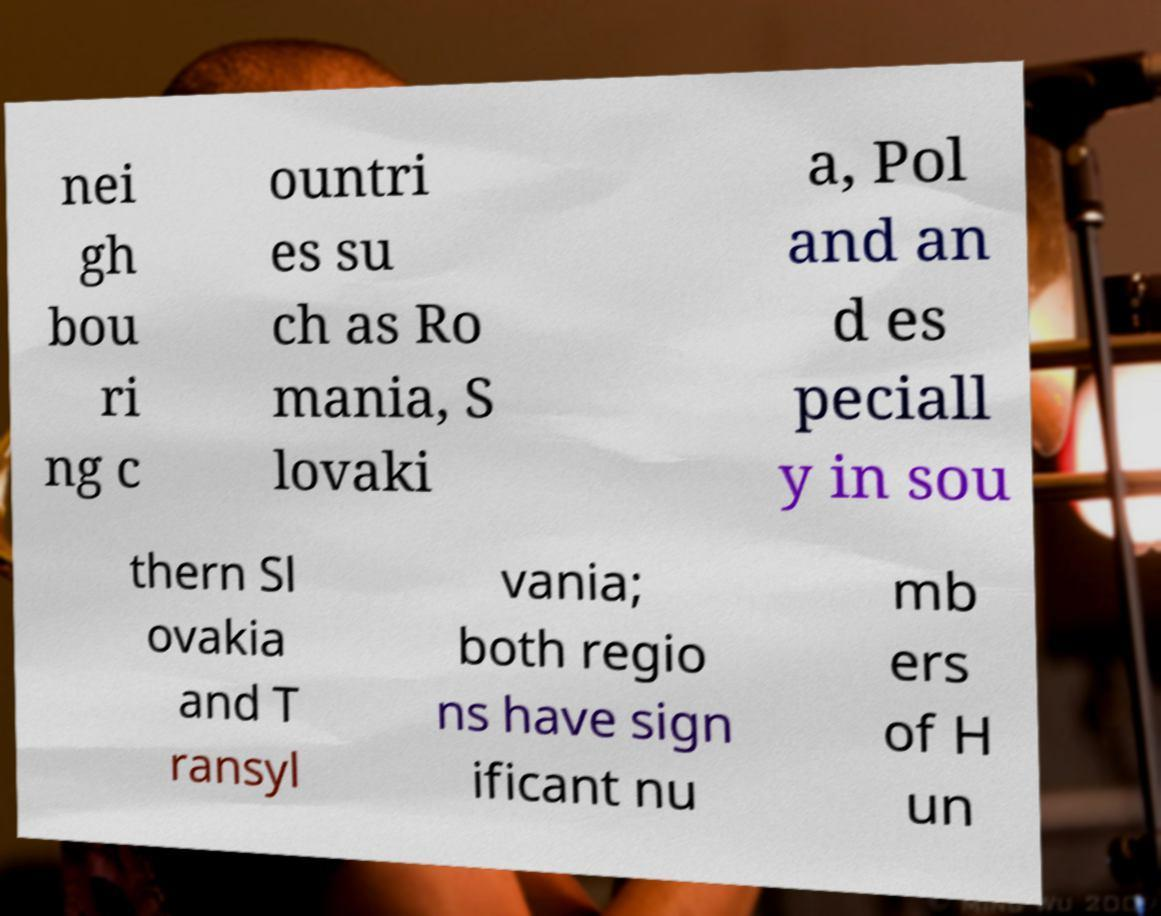Could you assist in decoding the text presented in this image and type it out clearly? nei gh bou ri ng c ountri es su ch as Ro mania, S lovaki a, Pol and an d es peciall y in sou thern Sl ovakia and T ransyl vania; both regio ns have sign ificant nu mb ers of H un 